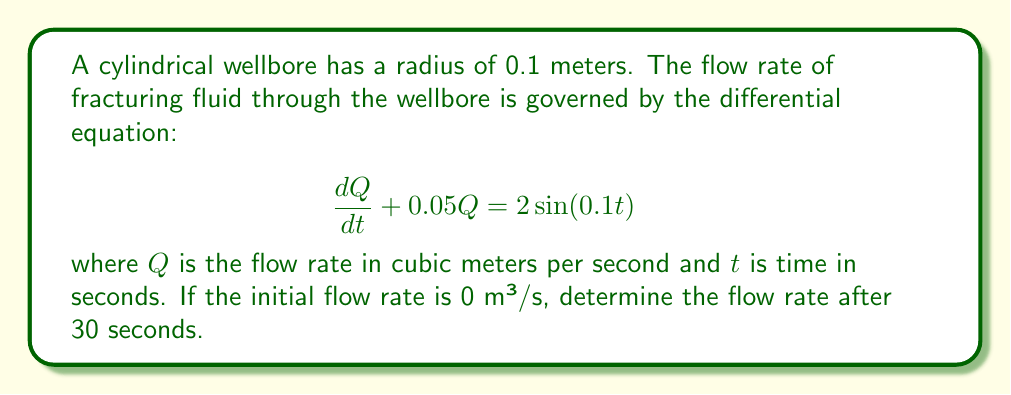Can you answer this question? To solve this first-order linear differential equation, we'll use the integrating factor method:

1) The integrating factor is $\mu(t) = e^{\int 0.05 dt} = e^{0.05t}$

2) Multiply both sides of the equation by the integrating factor:

   $e^{0.05t}\frac{dQ}{dt} + 0.05e^{0.05t}Q = 2e^{0.05t}\sin(0.1t)$

3) The left side is now the derivative of $e^{0.05t}Q$:

   $\frac{d}{dt}(e^{0.05t}Q) = 2e^{0.05t}\sin(0.1t)$

4) Integrate both sides:

   $e^{0.05t}Q = \int 2e^{0.05t}\sin(0.1t)dt$

5) To solve the integral, use integration by parts twice:

   $\int e^{0.05t}\sin(0.1t)dt = \frac{e^{0.05t}(2\sin(0.1t) - \cos(0.1t))}{1.25} + C$

6) Therefore, the general solution is:

   $Q = \frac{2(2\sin(0.1t) - \cos(0.1t))}{1.25} + Ce^{-0.05t}$

7) Apply the initial condition $Q(0) = 0$ to find $C$:

   $0 = \frac{2(-1)}{1.25} + C$
   $C = \frac{8}{5} = 1.6$

8) The particular solution is:

   $Q = \frac{2(2\sin(0.1t) - \cos(0.1t))}{1.25} + 1.6e^{-0.05t}$

9) Evaluate at $t = 30$:

   $Q(30) = \frac{2(2\sin(3) - \cos(3))}{1.25} + 1.6e^{-1.5}$

10) Calculate the numerical value:

    $Q(30) \approx 2.7101$ m³/s
Answer: The flow rate after 30 seconds is approximately 2.7101 m³/s. 